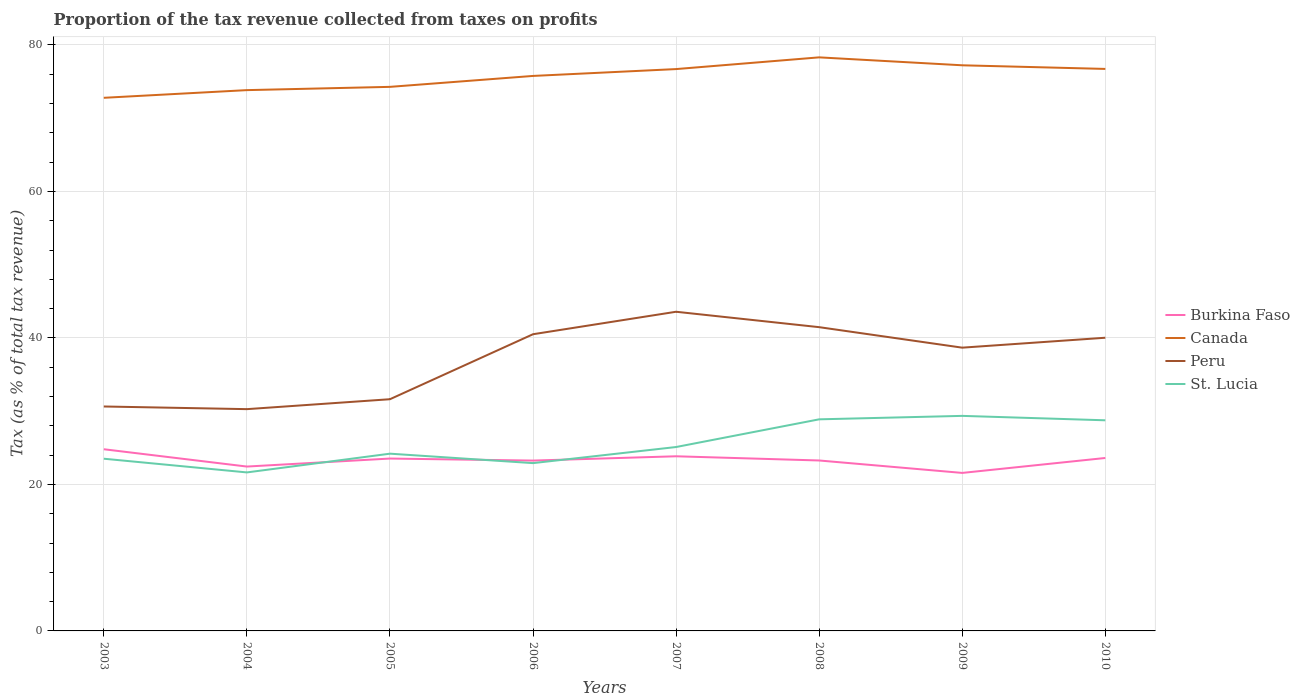How many different coloured lines are there?
Provide a short and direct response. 4. Is the number of lines equal to the number of legend labels?
Give a very brief answer. Yes. Across all years, what is the maximum proportion of the tax revenue collected in St. Lucia?
Give a very brief answer. 21.64. In which year was the proportion of the tax revenue collected in Burkina Faso maximum?
Keep it short and to the point. 2009. What is the total proportion of the tax revenue collected in St. Lucia in the graph?
Provide a short and direct response. -2.2. What is the difference between the highest and the second highest proportion of the tax revenue collected in Burkina Faso?
Offer a terse response. 3.23. What is the difference between the highest and the lowest proportion of the tax revenue collected in Canada?
Provide a short and direct response. 5. Is the proportion of the tax revenue collected in St. Lucia strictly greater than the proportion of the tax revenue collected in Peru over the years?
Offer a very short reply. Yes. Are the values on the major ticks of Y-axis written in scientific E-notation?
Make the answer very short. No. Does the graph contain any zero values?
Give a very brief answer. No. How many legend labels are there?
Keep it short and to the point. 4. How are the legend labels stacked?
Give a very brief answer. Vertical. What is the title of the graph?
Your answer should be compact. Proportion of the tax revenue collected from taxes on profits. Does "Panama" appear as one of the legend labels in the graph?
Offer a terse response. No. What is the label or title of the X-axis?
Your answer should be compact. Years. What is the label or title of the Y-axis?
Keep it short and to the point. Tax (as % of total tax revenue). What is the Tax (as % of total tax revenue) of Burkina Faso in 2003?
Ensure brevity in your answer.  24.8. What is the Tax (as % of total tax revenue) in Canada in 2003?
Your response must be concise. 72.78. What is the Tax (as % of total tax revenue) of Peru in 2003?
Your answer should be very brief. 30.64. What is the Tax (as % of total tax revenue) in St. Lucia in 2003?
Offer a terse response. 23.51. What is the Tax (as % of total tax revenue) in Burkina Faso in 2004?
Your response must be concise. 22.44. What is the Tax (as % of total tax revenue) of Canada in 2004?
Your answer should be compact. 73.83. What is the Tax (as % of total tax revenue) of Peru in 2004?
Provide a short and direct response. 30.28. What is the Tax (as % of total tax revenue) of St. Lucia in 2004?
Ensure brevity in your answer.  21.64. What is the Tax (as % of total tax revenue) in Burkina Faso in 2005?
Offer a terse response. 23.53. What is the Tax (as % of total tax revenue) of Canada in 2005?
Your answer should be very brief. 74.28. What is the Tax (as % of total tax revenue) in Peru in 2005?
Ensure brevity in your answer.  31.63. What is the Tax (as % of total tax revenue) in St. Lucia in 2005?
Keep it short and to the point. 24.2. What is the Tax (as % of total tax revenue) of Burkina Faso in 2006?
Your response must be concise. 23.26. What is the Tax (as % of total tax revenue) in Canada in 2006?
Keep it short and to the point. 75.77. What is the Tax (as % of total tax revenue) of Peru in 2006?
Your response must be concise. 40.5. What is the Tax (as % of total tax revenue) of St. Lucia in 2006?
Keep it short and to the point. 22.91. What is the Tax (as % of total tax revenue) of Burkina Faso in 2007?
Ensure brevity in your answer.  23.84. What is the Tax (as % of total tax revenue) of Canada in 2007?
Make the answer very short. 76.7. What is the Tax (as % of total tax revenue) of Peru in 2007?
Offer a very short reply. 43.57. What is the Tax (as % of total tax revenue) in St. Lucia in 2007?
Make the answer very short. 25.11. What is the Tax (as % of total tax revenue) of Burkina Faso in 2008?
Your answer should be very brief. 23.27. What is the Tax (as % of total tax revenue) in Canada in 2008?
Your answer should be compact. 78.3. What is the Tax (as % of total tax revenue) of Peru in 2008?
Ensure brevity in your answer.  41.47. What is the Tax (as % of total tax revenue) in St. Lucia in 2008?
Offer a very short reply. 28.89. What is the Tax (as % of total tax revenue) in Burkina Faso in 2009?
Offer a very short reply. 21.57. What is the Tax (as % of total tax revenue) in Canada in 2009?
Give a very brief answer. 77.22. What is the Tax (as % of total tax revenue) in Peru in 2009?
Make the answer very short. 38.67. What is the Tax (as % of total tax revenue) of St. Lucia in 2009?
Keep it short and to the point. 29.36. What is the Tax (as % of total tax revenue) in Burkina Faso in 2010?
Provide a short and direct response. 23.61. What is the Tax (as % of total tax revenue) in Canada in 2010?
Ensure brevity in your answer.  76.72. What is the Tax (as % of total tax revenue) of Peru in 2010?
Keep it short and to the point. 40.03. What is the Tax (as % of total tax revenue) in St. Lucia in 2010?
Your answer should be very brief. 28.76. Across all years, what is the maximum Tax (as % of total tax revenue) of Burkina Faso?
Offer a very short reply. 24.8. Across all years, what is the maximum Tax (as % of total tax revenue) of Canada?
Offer a very short reply. 78.3. Across all years, what is the maximum Tax (as % of total tax revenue) in Peru?
Keep it short and to the point. 43.57. Across all years, what is the maximum Tax (as % of total tax revenue) of St. Lucia?
Your response must be concise. 29.36. Across all years, what is the minimum Tax (as % of total tax revenue) in Burkina Faso?
Provide a short and direct response. 21.57. Across all years, what is the minimum Tax (as % of total tax revenue) of Canada?
Offer a terse response. 72.78. Across all years, what is the minimum Tax (as % of total tax revenue) of Peru?
Your response must be concise. 30.28. Across all years, what is the minimum Tax (as % of total tax revenue) in St. Lucia?
Your answer should be very brief. 21.64. What is the total Tax (as % of total tax revenue) of Burkina Faso in the graph?
Your answer should be compact. 186.32. What is the total Tax (as % of total tax revenue) of Canada in the graph?
Your response must be concise. 605.61. What is the total Tax (as % of total tax revenue) of Peru in the graph?
Ensure brevity in your answer.  296.79. What is the total Tax (as % of total tax revenue) of St. Lucia in the graph?
Give a very brief answer. 204.37. What is the difference between the Tax (as % of total tax revenue) of Burkina Faso in 2003 and that in 2004?
Provide a succinct answer. 2.36. What is the difference between the Tax (as % of total tax revenue) of Canada in 2003 and that in 2004?
Offer a very short reply. -1.05. What is the difference between the Tax (as % of total tax revenue) of Peru in 2003 and that in 2004?
Offer a very short reply. 0.36. What is the difference between the Tax (as % of total tax revenue) of St. Lucia in 2003 and that in 2004?
Offer a terse response. 1.87. What is the difference between the Tax (as % of total tax revenue) of Burkina Faso in 2003 and that in 2005?
Offer a terse response. 1.27. What is the difference between the Tax (as % of total tax revenue) in Canada in 2003 and that in 2005?
Keep it short and to the point. -1.49. What is the difference between the Tax (as % of total tax revenue) in Peru in 2003 and that in 2005?
Make the answer very short. -0.99. What is the difference between the Tax (as % of total tax revenue) in St. Lucia in 2003 and that in 2005?
Ensure brevity in your answer.  -0.69. What is the difference between the Tax (as % of total tax revenue) in Burkina Faso in 2003 and that in 2006?
Keep it short and to the point. 1.55. What is the difference between the Tax (as % of total tax revenue) in Canada in 2003 and that in 2006?
Your response must be concise. -2.99. What is the difference between the Tax (as % of total tax revenue) in Peru in 2003 and that in 2006?
Your answer should be very brief. -9.86. What is the difference between the Tax (as % of total tax revenue) of St. Lucia in 2003 and that in 2006?
Make the answer very short. 0.6. What is the difference between the Tax (as % of total tax revenue) in Burkina Faso in 2003 and that in 2007?
Your answer should be compact. 0.96. What is the difference between the Tax (as % of total tax revenue) in Canada in 2003 and that in 2007?
Provide a short and direct response. -3.92. What is the difference between the Tax (as % of total tax revenue) in Peru in 2003 and that in 2007?
Offer a terse response. -12.93. What is the difference between the Tax (as % of total tax revenue) in St. Lucia in 2003 and that in 2007?
Provide a short and direct response. -1.6. What is the difference between the Tax (as % of total tax revenue) in Burkina Faso in 2003 and that in 2008?
Make the answer very short. 1.54. What is the difference between the Tax (as % of total tax revenue) of Canada in 2003 and that in 2008?
Your answer should be compact. -5.52. What is the difference between the Tax (as % of total tax revenue) in Peru in 2003 and that in 2008?
Your response must be concise. -10.83. What is the difference between the Tax (as % of total tax revenue) of St. Lucia in 2003 and that in 2008?
Make the answer very short. -5.38. What is the difference between the Tax (as % of total tax revenue) of Burkina Faso in 2003 and that in 2009?
Your answer should be compact. 3.23. What is the difference between the Tax (as % of total tax revenue) in Canada in 2003 and that in 2009?
Offer a very short reply. -4.44. What is the difference between the Tax (as % of total tax revenue) of Peru in 2003 and that in 2009?
Provide a short and direct response. -8.03. What is the difference between the Tax (as % of total tax revenue) in St. Lucia in 2003 and that in 2009?
Offer a terse response. -5.85. What is the difference between the Tax (as % of total tax revenue) of Burkina Faso in 2003 and that in 2010?
Your answer should be very brief. 1.19. What is the difference between the Tax (as % of total tax revenue) in Canada in 2003 and that in 2010?
Keep it short and to the point. -3.94. What is the difference between the Tax (as % of total tax revenue) of Peru in 2003 and that in 2010?
Give a very brief answer. -9.39. What is the difference between the Tax (as % of total tax revenue) of St. Lucia in 2003 and that in 2010?
Your answer should be compact. -5.25. What is the difference between the Tax (as % of total tax revenue) of Burkina Faso in 2004 and that in 2005?
Your answer should be compact. -1.09. What is the difference between the Tax (as % of total tax revenue) in Canada in 2004 and that in 2005?
Keep it short and to the point. -0.45. What is the difference between the Tax (as % of total tax revenue) in Peru in 2004 and that in 2005?
Provide a succinct answer. -1.35. What is the difference between the Tax (as % of total tax revenue) in St. Lucia in 2004 and that in 2005?
Offer a very short reply. -2.56. What is the difference between the Tax (as % of total tax revenue) of Burkina Faso in 2004 and that in 2006?
Your answer should be compact. -0.82. What is the difference between the Tax (as % of total tax revenue) of Canada in 2004 and that in 2006?
Offer a terse response. -1.94. What is the difference between the Tax (as % of total tax revenue) in Peru in 2004 and that in 2006?
Give a very brief answer. -10.23. What is the difference between the Tax (as % of total tax revenue) of St. Lucia in 2004 and that in 2006?
Ensure brevity in your answer.  -1.27. What is the difference between the Tax (as % of total tax revenue) of Burkina Faso in 2004 and that in 2007?
Ensure brevity in your answer.  -1.4. What is the difference between the Tax (as % of total tax revenue) of Canada in 2004 and that in 2007?
Give a very brief answer. -2.87. What is the difference between the Tax (as % of total tax revenue) in Peru in 2004 and that in 2007?
Offer a terse response. -13.3. What is the difference between the Tax (as % of total tax revenue) in St. Lucia in 2004 and that in 2007?
Keep it short and to the point. -3.47. What is the difference between the Tax (as % of total tax revenue) in Burkina Faso in 2004 and that in 2008?
Make the answer very short. -0.83. What is the difference between the Tax (as % of total tax revenue) of Canada in 2004 and that in 2008?
Offer a very short reply. -4.47. What is the difference between the Tax (as % of total tax revenue) of Peru in 2004 and that in 2008?
Your answer should be compact. -11.19. What is the difference between the Tax (as % of total tax revenue) in St. Lucia in 2004 and that in 2008?
Your response must be concise. -7.25. What is the difference between the Tax (as % of total tax revenue) of Burkina Faso in 2004 and that in 2009?
Offer a very short reply. 0.87. What is the difference between the Tax (as % of total tax revenue) in Canada in 2004 and that in 2009?
Provide a short and direct response. -3.39. What is the difference between the Tax (as % of total tax revenue) in Peru in 2004 and that in 2009?
Ensure brevity in your answer.  -8.39. What is the difference between the Tax (as % of total tax revenue) in St. Lucia in 2004 and that in 2009?
Offer a very short reply. -7.72. What is the difference between the Tax (as % of total tax revenue) of Burkina Faso in 2004 and that in 2010?
Give a very brief answer. -1.17. What is the difference between the Tax (as % of total tax revenue) of Canada in 2004 and that in 2010?
Make the answer very short. -2.89. What is the difference between the Tax (as % of total tax revenue) in Peru in 2004 and that in 2010?
Your response must be concise. -9.75. What is the difference between the Tax (as % of total tax revenue) in St. Lucia in 2004 and that in 2010?
Give a very brief answer. -7.12. What is the difference between the Tax (as % of total tax revenue) in Burkina Faso in 2005 and that in 2006?
Your answer should be very brief. 0.28. What is the difference between the Tax (as % of total tax revenue) in Canada in 2005 and that in 2006?
Give a very brief answer. -1.49. What is the difference between the Tax (as % of total tax revenue) of Peru in 2005 and that in 2006?
Keep it short and to the point. -8.87. What is the difference between the Tax (as % of total tax revenue) of St. Lucia in 2005 and that in 2006?
Keep it short and to the point. 1.29. What is the difference between the Tax (as % of total tax revenue) in Burkina Faso in 2005 and that in 2007?
Make the answer very short. -0.31. What is the difference between the Tax (as % of total tax revenue) in Canada in 2005 and that in 2007?
Offer a terse response. -2.43. What is the difference between the Tax (as % of total tax revenue) in Peru in 2005 and that in 2007?
Your answer should be very brief. -11.94. What is the difference between the Tax (as % of total tax revenue) in St. Lucia in 2005 and that in 2007?
Offer a terse response. -0.91. What is the difference between the Tax (as % of total tax revenue) of Burkina Faso in 2005 and that in 2008?
Offer a terse response. 0.26. What is the difference between the Tax (as % of total tax revenue) in Canada in 2005 and that in 2008?
Your answer should be compact. -4.03. What is the difference between the Tax (as % of total tax revenue) in Peru in 2005 and that in 2008?
Your answer should be compact. -9.84. What is the difference between the Tax (as % of total tax revenue) of St. Lucia in 2005 and that in 2008?
Give a very brief answer. -4.69. What is the difference between the Tax (as % of total tax revenue) of Burkina Faso in 2005 and that in 2009?
Your answer should be very brief. 1.96. What is the difference between the Tax (as % of total tax revenue) of Canada in 2005 and that in 2009?
Offer a terse response. -2.94. What is the difference between the Tax (as % of total tax revenue) of Peru in 2005 and that in 2009?
Offer a terse response. -7.04. What is the difference between the Tax (as % of total tax revenue) of St. Lucia in 2005 and that in 2009?
Provide a short and direct response. -5.16. What is the difference between the Tax (as % of total tax revenue) in Burkina Faso in 2005 and that in 2010?
Your response must be concise. -0.08. What is the difference between the Tax (as % of total tax revenue) of Canada in 2005 and that in 2010?
Ensure brevity in your answer.  -2.45. What is the difference between the Tax (as % of total tax revenue) in Peru in 2005 and that in 2010?
Keep it short and to the point. -8.39. What is the difference between the Tax (as % of total tax revenue) in St. Lucia in 2005 and that in 2010?
Offer a very short reply. -4.56. What is the difference between the Tax (as % of total tax revenue) of Burkina Faso in 2006 and that in 2007?
Offer a very short reply. -0.59. What is the difference between the Tax (as % of total tax revenue) in Canada in 2006 and that in 2007?
Your answer should be very brief. -0.94. What is the difference between the Tax (as % of total tax revenue) of Peru in 2006 and that in 2007?
Your response must be concise. -3.07. What is the difference between the Tax (as % of total tax revenue) of St. Lucia in 2006 and that in 2007?
Make the answer very short. -2.2. What is the difference between the Tax (as % of total tax revenue) of Burkina Faso in 2006 and that in 2008?
Provide a short and direct response. -0.01. What is the difference between the Tax (as % of total tax revenue) in Canada in 2006 and that in 2008?
Your response must be concise. -2.54. What is the difference between the Tax (as % of total tax revenue) of Peru in 2006 and that in 2008?
Your response must be concise. -0.96. What is the difference between the Tax (as % of total tax revenue) in St. Lucia in 2006 and that in 2008?
Provide a succinct answer. -5.98. What is the difference between the Tax (as % of total tax revenue) in Burkina Faso in 2006 and that in 2009?
Your answer should be very brief. 1.68. What is the difference between the Tax (as % of total tax revenue) in Canada in 2006 and that in 2009?
Your answer should be very brief. -1.45. What is the difference between the Tax (as % of total tax revenue) of Peru in 2006 and that in 2009?
Your response must be concise. 1.83. What is the difference between the Tax (as % of total tax revenue) in St. Lucia in 2006 and that in 2009?
Offer a very short reply. -6.45. What is the difference between the Tax (as % of total tax revenue) in Burkina Faso in 2006 and that in 2010?
Offer a terse response. -0.36. What is the difference between the Tax (as % of total tax revenue) of Canada in 2006 and that in 2010?
Offer a very short reply. -0.96. What is the difference between the Tax (as % of total tax revenue) in Peru in 2006 and that in 2010?
Offer a terse response. 0.48. What is the difference between the Tax (as % of total tax revenue) of St. Lucia in 2006 and that in 2010?
Ensure brevity in your answer.  -5.85. What is the difference between the Tax (as % of total tax revenue) in Burkina Faso in 2007 and that in 2008?
Keep it short and to the point. 0.57. What is the difference between the Tax (as % of total tax revenue) in Canada in 2007 and that in 2008?
Make the answer very short. -1.6. What is the difference between the Tax (as % of total tax revenue) of Peru in 2007 and that in 2008?
Provide a short and direct response. 2.1. What is the difference between the Tax (as % of total tax revenue) in St. Lucia in 2007 and that in 2008?
Make the answer very short. -3.78. What is the difference between the Tax (as % of total tax revenue) in Burkina Faso in 2007 and that in 2009?
Offer a very short reply. 2.27. What is the difference between the Tax (as % of total tax revenue) of Canada in 2007 and that in 2009?
Your answer should be compact. -0.52. What is the difference between the Tax (as % of total tax revenue) in Peru in 2007 and that in 2009?
Provide a short and direct response. 4.9. What is the difference between the Tax (as % of total tax revenue) in St. Lucia in 2007 and that in 2009?
Your answer should be very brief. -4.25. What is the difference between the Tax (as % of total tax revenue) in Burkina Faso in 2007 and that in 2010?
Your response must be concise. 0.23. What is the difference between the Tax (as % of total tax revenue) of Canada in 2007 and that in 2010?
Offer a very short reply. -0.02. What is the difference between the Tax (as % of total tax revenue) in Peru in 2007 and that in 2010?
Give a very brief answer. 3.55. What is the difference between the Tax (as % of total tax revenue) in St. Lucia in 2007 and that in 2010?
Offer a terse response. -3.65. What is the difference between the Tax (as % of total tax revenue) in Burkina Faso in 2008 and that in 2009?
Ensure brevity in your answer.  1.7. What is the difference between the Tax (as % of total tax revenue) of Canada in 2008 and that in 2009?
Your answer should be compact. 1.08. What is the difference between the Tax (as % of total tax revenue) in Peru in 2008 and that in 2009?
Make the answer very short. 2.8. What is the difference between the Tax (as % of total tax revenue) in St. Lucia in 2008 and that in 2009?
Your answer should be compact. -0.47. What is the difference between the Tax (as % of total tax revenue) in Burkina Faso in 2008 and that in 2010?
Your response must be concise. -0.34. What is the difference between the Tax (as % of total tax revenue) in Canada in 2008 and that in 2010?
Offer a very short reply. 1.58. What is the difference between the Tax (as % of total tax revenue) of Peru in 2008 and that in 2010?
Your answer should be very brief. 1.44. What is the difference between the Tax (as % of total tax revenue) of St. Lucia in 2008 and that in 2010?
Your response must be concise. 0.13. What is the difference between the Tax (as % of total tax revenue) of Burkina Faso in 2009 and that in 2010?
Provide a succinct answer. -2.04. What is the difference between the Tax (as % of total tax revenue) of Canada in 2009 and that in 2010?
Ensure brevity in your answer.  0.5. What is the difference between the Tax (as % of total tax revenue) in Peru in 2009 and that in 2010?
Give a very brief answer. -1.35. What is the difference between the Tax (as % of total tax revenue) in St. Lucia in 2009 and that in 2010?
Give a very brief answer. 0.6. What is the difference between the Tax (as % of total tax revenue) of Burkina Faso in 2003 and the Tax (as % of total tax revenue) of Canada in 2004?
Your answer should be compact. -49.03. What is the difference between the Tax (as % of total tax revenue) of Burkina Faso in 2003 and the Tax (as % of total tax revenue) of Peru in 2004?
Your response must be concise. -5.47. What is the difference between the Tax (as % of total tax revenue) of Burkina Faso in 2003 and the Tax (as % of total tax revenue) of St. Lucia in 2004?
Keep it short and to the point. 3.16. What is the difference between the Tax (as % of total tax revenue) of Canada in 2003 and the Tax (as % of total tax revenue) of Peru in 2004?
Keep it short and to the point. 42.51. What is the difference between the Tax (as % of total tax revenue) in Canada in 2003 and the Tax (as % of total tax revenue) in St. Lucia in 2004?
Provide a succinct answer. 51.14. What is the difference between the Tax (as % of total tax revenue) in Peru in 2003 and the Tax (as % of total tax revenue) in St. Lucia in 2004?
Give a very brief answer. 9. What is the difference between the Tax (as % of total tax revenue) of Burkina Faso in 2003 and the Tax (as % of total tax revenue) of Canada in 2005?
Provide a short and direct response. -49.47. What is the difference between the Tax (as % of total tax revenue) of Burkina Faso in 2003 and the Tax (as % of total tax revenue) of Peru in 2005?
Keep it short and to the point. -6.83. What is the difference between the Tax (as % of total tax revenue) in Burkina Faso in 2003 and the Tax (as % of total tax revenue) in St. Lucia in 2005?
Keep it short and to the point. 0.61. What is the difference between the Tax (as % of total tax revenue) of Canada in 2003 and the Tax (as % of total tax revenue) of Peru in 2005?
Offer a very short reply. 41.15. What is the difference between the Tax (as % of total tax revenue) of Canada in 2003 and the Tax (as % of total tax revenue) of St. Lucia in 2005?
Your answer should be very brief. 48.58. What is the difference between the Tax (as % of total tax revenue) of Peru in 2003 and the Tax (as % of total tax revenue) of St. Lucia in 2005?
Provide a short and direct response. 6.44. What is the difference between the Tax (as % of total tax revenue) in Burkina Faso in 2003 and the Tax (as % of total tax revenue) in Canada in 2006?
Give a very brief answer. -50.96. What is the difference between the Tax (as % of total tax revenue) in Burkina Faso in 2003 and the Tax (as % of total tax revenue) in Peru in 2006?
Offer a terse response. -15.7. What is the difference between the Tax (as % of total tax revenue) of Burkina Faso in 2003 and the Tax (as % of total tax revenue) of St. Lucia in 2006?
Make the answer very short. 1.9. What is the difference between the Tax (as % of total tax revenue) in Canada in 2003 and the Tax (as % of total tax revenue) in Peru in 2006?
Make the answer very short. 32.28. What is the difference between the Tax (as % of total tax revenue) of Canada in 2003 and the Tax (as % of total tax revenue) of St. Lucia in 2006?
Provide a short and direct response. 49.87. What is the difference between the Tax (as % of total tax revenue) in Peru in 2003 and the Tax (as % of total tax revenue) in St. Lucia in 2006?
Provide a short and direct response. 7.73. What is the difference between the Tax (as % of total tax revenue) of Burkina Faso in 2003 and the Tax (as % of total tax revenue) of Canada in 2007?
Provide a succinct answer. -51.9. What is the difference between the Tax (as % of total tax revenue) in Burkina Faso in 2003 and the Tax (as % of total tax revenue) in Peru in 2007?
Your answer should be very brief. -18.77. What is the difference between the Tax (as % of total tax revenue) of Burkina Faso in 2003 and the Tax (as % of total tax revenue) of St. Lucia in 2007?
Offer a very short reply. -0.3. What is the difference between the Tax (as % of total tax revenue) of Canada in 2003 and the Tax (as % of total tax revenue) of Peru in 2007?
Keep it short and to the point. 29.21. What is the difference between the Tax (as % of total tax revenue) of Canada in 2003 and the Tax (as % of total tax revenue) of St. Lucia in 2007?
Give a very brief answer. 47.68. What is the difference between the Tax (as % of total tax revenue) of Peru in 2003 and the Tax (as % of total tax revenue) of St. Lucia in 2007?
Provide a succinct answer. 5.53. What is the difference between the Tax (as % of total tax revenue) in Burkina Faso in 2003 and the Tax (as % of total tax revenue) in Canada in 2008?
Offer a terse response. -53.5. What is the difference between the Tax (as % of total tax revenue) of Burkina Faso in 2003 and the Tax (as % of total tax revenue) of Peru in 2008?
Keep it short and to the point. -16.67. What is the difference between the Tax (as % of total tax revenue) of Burkina Faso in 2003 and the Tax (as % of total tax revenue) of St. Lucia in 2008?
Your answer should be very brief. -4.08. What is the difference between the Tax (as % of total tax revenue) in Canada in 2003 and the Tax (as % of total tax revenue) in Peru in 2008?
Your response must be concise. 31.31. What is the difference between the Tax (as % of total tax revenue) in Canada in 2003 and the Tax (as % of total tax revenue) in St. Lucia in 2008?
Ensure brevity in your answer.  43.89. What is the difference between the Tax (as % of total tax revenue) in Peru in 2003 and the Tax (as % of total tax revenue) in St. Lucia in 2008?
Offer a terse response. 1.75. What is the difference between the Tax (as % of total tax revenue) of Burkina Faso in 2003 and the Tax (as % of total tax revenue) of Canada in 2009?
Offer a terse response. -52.42. What is the difference between the Tax (as % of total tax revenue) in Burkina Faso in 2003 and the Tax (as % of total tax revenue) in Peru in 2009?
Offer a terse response. -13.87. What is the difference between the Tax (as % of total tax revenue) of Burkina Faso in 2003 and the Tax (as % of total tax revenue) of St. Lucia in 2009?
Your response must be concise. -4.56. What is the difference between the Tax (as % of total tax revenue) in Canada in 2003 and the Tax (as % of total tax revenue) in Peru in 2009?
Offer a terse response. 34.11. What is the difference between the Tax (as % of total tax revenue) of Canada in 2003 and the Tax (as % of total tax revenue) of St. Lucia in 2009?
Your response must be concise. 43.42. What is the difference between the Tax (as % of total tax revenue) in Peru in 2003 and the Tax (as % of total tax revenue) in St. Lucia in 2009?
Your response must be concise. 1.28. What is the difference between the Tax (as % of total tax revenue) of Burkina Faso in 2003 and the Tax (as % of total tax revenue) of Canada in 2010?
Your answer should be very brief. -51.92. What is the difference between the Tax (as % of total tax revenue) in Burkina Faso in 2003 and the Tax (as % of total tax revenue) in Peru in 2010?
Ensure brevity in your answer.  -15.22. What is the difference between the Tax (as % of total tax revenue) of Burkina Faso in 2003 and the Tax (as % of total tax revenue) of St. Lucia in 2010?
Provide a short and direct response. -3.95. What is the difference between the Tax (as % of total tax revenue) in Canada in 2003 and the Tax (as % of total tax revenue) in Peru in 2010?
Offer a very short reply. 32.76. What is the difference between the Tax (as % of total tax revenue) of Canada in 2003 and the Tax (as % of total tax revenue) of St. Lucia in 2010?
Provide a succinct answer. 44.03. What is the difference between the Tax (as % of total tax revenue) in Peru in 2003 and the Tax (as % of total tax revenue) in St. Lucia in 2010?
Your answer should be compact. 1.88. What is the difference between the Tax (as % of total tax revenue) in Burkina Faso in 2004 and the Tax (as % of total tax revenue) in Canada in 2005?
Ensure brevity in your answer.  -51.84. What is the difference between the Tax (as % of total tax revenue) of Burkina Faso in 2004 and the Tax (as % of total tax revenue) of Peru in 2005?
Offer a terse response. -9.19. What is the difference between the Tax (as % of total tax revenue) of Burkina Faso in 2004 and the Tax (as % of total tax revenue) of St. Lucia in 2005?
Your answer should be very brief. -1.76. What is the difference between the Tax (as % of total tax revenue) in Canada in 2004 and the Tax (as % of total tax revenue) in Peru in 2005?
Keep it short and to the point. 42.2. What is the difference between the Tax (as % of total tax revenue) in Canada in 2004 and the Tax (as % of total tax revenue) in St. Lucia in 2005?
Your answer should be very brief. 49.63. What is the difference between the Tax (as % of total tax revenue) of Peru in 2004 and the Tax (as % of total tax revenue) of St. Lucia in 2005?
Your answer should be very brief. 6.08. What is the difference between the Tax (as % of total tax revenue) of Burkina Faso in 2004 and the Tax (as % of total tax revenue) of Canada in 2006?
Ensure brevity in your answer.  -53.33. What is the difference between the Tax (as % of total tax revenue) of Burkina Faso in 2004 and the Tax (as % of total tax revenue) of Peru in 2006?
Provide a short and direct response. -18.07. What is the difference between the Tax (as % of total tax revenue) of Burkina Faso in 2004 and the Tax (as % of total tax revenue) of St. Lucia in 2006?
Offer a very short reply. -0.47. What is the difference between the Tax (as % of total tax revenue) in Canada in 2004 and the Tax (as % of total tax revenue) in Peru in 2006?
Provide a short and direct response. 33.33. What is the difference between the Tax (as % of total tax revenue) in Canada in 2004 and the Tax (as % of total tax revenue) in St. Lucia in 2006?
Provide a succinct answer. 50.92. What is the difference between the Tax (as % of total tax revenue) of Peru in 2004 and the Tax (as % of total tax revenue) of St. Lucia in 2006?
Keep it short and to the point. 7.37. What is the difference between the Tax (as % of total tax revenue) in Burkina Faso in 2004 and the Tax (as % of total tax revenue) in Canada in 2007?
Offer a terse response. -54.26. What is the difference between the Tax (as % of total tax revenue) of Burkina Faso in 2004 and the Tax (as % of total tax revenue) of Peru in 2007?
Keep it short and to the point. -21.13. What is the difference between the Tax (as % of total tax revenue) of Burkina Faso in 2004 and the Tax (as % of total tax revenue) of St. Lucia in 2007?
Keep it short and to the point. -2.67. What is the difference between the Tax (as % of total tax revenue) of Canada in 2004 and the Tax (as % of total tax revenue) of Peru in 2007?
Make the answer very short. 30.26. What is the difference between the Tax (as % of total tax revenue) in Canada in 2004 and the Tax (as % of total tax revenue) in St. Lucia in 2007?
Offer a very short reply. 48.72. What is the difference between the Tax (as % of total tax revenue) in Peru in 2004 and the Tax (as % of total tax revenue) in St. Lucia in 2007?
Ensure brevity in your answer.  5.17. What is the difference between the Tax (as % of total tax revenue) of Burkina Faso in 2004 and the Tax (as % of total tax revenue) of Canada in 2008?
Provide a succinct answer. -55.87. What is the difference between the Tax (as % of total tax revenue) in Burkina Faso in 2004 and the Tax (as % of total tax revenue) in Peru in 2008?
Ensure brevity in your answer.  -19.03. What is the difference between the Tax (as % of total tax revenue) of Burkina Faso in 2004 and the Tax (as % of total tax revenue) of St. Lucia in 2008?
Offer a very short reply. -6.45. What is the difference between the Tax (as % of total tax revenue) of Canada in 2004 and the Tax (as % of total tax revenue) of Peru in 2008?
Your response must be concise. 32.36. What is the difference between the Tax (as % of total tax revenue) in Canada in 2004 and the Tax (as % of total tax revenue) in St. Lucia in 2008?
Make the answer very short. 44.94. What is the difference between the Tax (as % of total tax revenue) in Peru in 2004 and the Tax (as % of total tax revenue) in St. Lucia in 2008?
Offer a very short reply. 1.39. What is the difference between the Tax (as % of total tax revenue) in Burkina Faso in 2004 and the Tax (as % of total tax revenue) in Canada in 2009?
Give a very brief answer. -54.78. What is the difference between the Tax (as % of total tax revenue) of Burkina Faso in 2004 and the Tax (as % of total tax revenue) of Peru in 2009?
Ensure brevity in your answer.  -16.23. What is the difference between the Tax (as % of total tax revenue) of Burkina Faso in 2004 and the Tax (as % of total tax revenue) of St. Lucia in 2009?
Offer a terse response. -6.92. What is the difference between the Tax (as % of total tax revenue) in Canada in 2004 and the Tax (as % of total tax revenue) in Peru in 2009?
Your answer should be compact. 35.16. What is the difference between the Tax (as % of total tax revenue) of Canada in 2004 and the Tax (as % of total tax revenue) of St. Lucia in 2009?
Provide a short and direct response. 44.47. What is the difference between the Tax (as % of total tax revenue) of Peru in 2004 and the Tax (as % of total tax revenue) of St. Lucia in 2009?
Keep it short and to the point. 0.92. What is the difference between the Tax (as % of total tax revenue) of Burkina Faso in 2004 and the Tax (as % of total tax revenue) of Canada in 2010?
Ensure brevity in your answer.  -54.28. What is the difference between the Tax (as % of total tax revenue) in Burkina Faso in 2004 and the Tax (as % of total tax revenue) in Peru in 2010?
Offer a very short reply. -17.59. What is the difference between the Tax (as % of total tax revenue) of Burkina Faso in 2004 and the Tax (as % of total tax revenue) of St. Lucia in 2010?
Your answer should be very brief. -6.32. What is the difference between the Tax (as % of total tax revenue) of Canada in 2004 and the Tax (as % of total tax revenue) of Peru in 2010?
Offer a very short reply. 33.8. What is the difference between the Tax (as % of total tax revenue) of Canada in 2004 and the Tax (as % of total tax revenue) of St. Lucia in 2010?
Provide a succinct answer. 45.07. What is the difference between the Tax (as % of total tax revenue) of Peru in 2004 and the Tax (as % of total tax revenue) of St. Lucia in 2010?
Ensure brevity in your answer.  1.52. What is the difference between the Tax (as % of total tax revenue) in Burkina Faso in 2005 and the Tax (as % of total tax revenue) in Canada in 2006?
Provide a short and direct response. -52.24. What is the difference between the Tax (as % of total tax revenue) in Burkina Faso in 2005 and the Tax (as % of total tax revenue) in Peru in 2006?
Offer a terse response. -16.97. What is the difference between the Tax (as % of total tax revenue) of Burkina Faso in 2005 and the Tax (as % of total tax revenue) of St. Lucia in 2006?
Provide a short and direct response. 0.62. What is the difference between the Tax (as % of total tax revenue) in Canada in 2005 and the Tax (as % of total tax revenue) in Peru in 2006?
Provide a succinct answer. 33.77. What is the difference between the Tax (as % of total tax revenue) in Canada in 2005 and the Tax (as % of total tax revenue) in St. Lucia in 2006?
Provide a short and direct response. 51.37. What is the difference between the Tax (as % of total tax revenue) of Peru in 2005 and the Tax (as % of total tax revenue) of St. Lucia in 2006?
Provide a short and direct response. 8.72. What is the difference between the Tax (as % of total tax revenue) of Burkina Faso in 2005 and the Tax (as % of total tax revenue) of Canada in 2007?
Your response must be concise. -53.17. What is the difference between the Tax (as % of total tax revenue) in Burkina Faso in 2005 and the Tax (as % of total tax revenue) in Peru in 2007?
Give a very brief answer. -20.04. What is the difference between the Tax (as % of total tax revenue) of Burkina Faso in 2005 and the Tax (as % of total tax revenue) of St. Lucia in 2007?
Provide a short and direct response. -1.57. What is the difference between the Tax (as % of total tax revenue) in Canada in 2005 and the Tax (as % of total tax revenue) in Peru in 2007?
Your answer should be compact. 30.7. What is the difference between the Tax (as % of total tax revenue) of Canada in 2005 and the Tax (as % of total tax revenue) of St. Lucia in 2007?
Your answer should be very brief. 49.17. What is the difference between the Tax (as % of total tax revenue) in Peru in 2005 and the Tax (as % of total tax revenue) in St. Lucia in 2007?
Ensure brevity in your answer.  6.53. What is the difference between the Tax (as % of total tax revenue) in Burkina Faso in 2005 and the Tax (as % of total tax revenue) in Canada in 2008?
Keep it short and to the point. -54.77. What is the difference between the Tax (as % of total tax revenue) of Burkina Faso in 2005 and the Tax (as % of total tax revenue) of Peru in 2008?
Offer a terse response. -17.94. What is the difference between the Tax (as % of total tax revenue) of Burkina Faso in 2005 and the Tax (as % of total tax revenue) of St. Lucia in 2008?
Keep it short and to the point. -5.36. What is the difference between the Tax (as % of total tax revenue) in Canada in 2005 and the Tax (as % of total tax revenue) in Peru in 2008?
Give a very brief answer. 32.81. What is the difference between the Tax (as % of total tax revenue) of Canada in 2005 and the Tax (as % of total tax revenue) of St. Lucia in 2008?
Your answer should be compact. 45.39. What is the difference between the Tax (as % of total tax revenue) in Peru in 2005 and the Tax (as % of total tax revenue) in St. Lucia in 2008?
Provide a succinct answer. 2.74. What is the difference between the Tax (as % of total tax revenue) in Burkina Faso in 2005 and the Tax (as % of total tax revenue) in Canada in 2009?
Give a very brief answer. -53.69. What is the difference between the Tax (as % of total tax revenue) in Burkina Faso in 2005 and the Tax (as % of total tax revenue) in Peru in 2009?
Keep it short and to the point. -15.14. What is the difference between the Tax (as % of total tax revenue) in Burkina Faso in 2005 and the Tax (as % of total tax revenue) in St. Lucia in 2009?
Provide a succinct answer. -5.83. What is the difference between the Tax (as % of total tax revenue) in Canada in 2005 and the Tax (as % of total tax revenue) in Peru in 2009?
Your answer should be compact. 35.6. What is the difference between the Tax (as % of total tax revenue) of Canada in 2005 and the Tax (as % of total tax revenue) of St. Lucia in 2009?
Provide a succinct answer. 44.92. What is the difference between the Tax (as % of total tax revenue) of Peru in 2005 and the Tax (as % of total tax revenue) of St. Lucia in 2009?
Make the answer very short. 2.27. What is the difference between the Tax (as % of total tax revenue) in Burkina Faso in 2005 and the Tax (as % of total tax revenue) in Canada in 2010?
Your answer should be very brief. -53.19. What is the difference between the Tax (as % of total tax revenue) in Burkina Faso in 2005 and the Tax (as % of total tax revenue) in Peru in 2010?
Provide a succinct answer. -16.49. What is the difference between the Tax (as % of total tax revenue) in Burkina Faso in 2005 and the Tax (as % of total tax revenue) in St. Lucia in 2010?
Offer a terse response. -5.22. What is the difference between the Tax (as % of total tax revenue) of Canada in 2005 and the Tax (as % of total tax revenue) of Peru in 2010?
Keep it short and to the point. 34.25. What is the difference between the Tax (as % of total tax revenue) in Canada in 2005 and the Tax (as % of total tax revenue) in St. Lucia in 2010?
Your answer should be very brief. 45.52. What is the difference between the Tax (as % of total tax revenue) of Peru in 2005 and the Tax (as % of total tax revenue) of St. Lucia in 2010?
Offer a very short reply. 2.88. What is the difference between the Tax (as % of total tax revenue) in Burkina Faso in 2006 and the Tax (as % of total tax revenue) in Canada in 2007?
Offer a terse response. -53.45. What is the difference between the Tax (as % of total tax revenue) of Burkina Faso in 2006 and the Tax (as % of total tax revenue) of Peru in 2007?
Give a very brief answer. -20.32. What is the difference between the Tax (as % of total tax revenue) in Burkina Faso in 2006 and the Tax (as % of total tax revenue) in St. Lucia in 2007?
Offer a very short reply. -1.85. What is the difference between the Tax (as % of total tax revenue) in Canada in 2006 and the Tax (as % of total tax revenue) in Peru in 2007?
Give a very brief answer. 32.2. What is the difference between the Tax (as % of total tax revenue) of Canada in 2006 and the Tax (as % of total tax revenue) of St. Lucia in 2007?
Your answer should be very brief. 50.66. What is the difference between the Tax (as % of total tax revenue) of Peru in 2006 and the Tax (as % of total tax revenue) of St. Lucia in 2007?
Keep it short and to the point. 15.4. What is the difference between the Tax (as % of total tax revenue) in Burkina Faso in 2006 and the Tax (as % of total tax revenue) in Canada in 2008?
Provide a succinct answer. -55.05. What is the difference between the Tax (as % of total tax revenue) in Burkina Faso in 2006 and the Tax (as % of total tax revenue) in Peru in 2008?
Make the answer very short. -18.21. What is the difference between the Tax (as % of total tax revenue) in Burkina Faso in 2006 and the Tax (as % of total tax revenue) in St. Lucia in 2008?
Provide a short and direct response. -5.63. What is the difference between the Tax (as % of total tax revenue) in Canada in 2006 and the Tax (as % of total tax revenue) in Peru in 2008?
Give a very brief answer. 34.3. What is the difference between the Tax (as % of total tax revenue) of Canada in 2006 and the Tax (as % of total tax revenue) of St. Lucia in 2008?
Provide a succinct answer. 46.88. What is the difference between the Tax (as % of total tax revenue) of Peru in 2006 and the Tax (as % of total tax revenue) of St. Lucia in 2008?
Your answer should be compact. 11.62. What is the difference between the Tax (as % of total tax revenue) of Burkina Faso in 2006 and the Tax (as % of total tax revenue) of Canada in 2009?
Make the answer very short. -53.97. What is the difference between the Tax (as % of total tax revenue) in Burkina Faso in 2006 and the Tax (as % of total tax revenue) in Peru in 2009?
Give a very brief answer. -15.42. What is the difference between the Tax (as % of total tax revenue) of Burkina Faso in 2006 and the Tax (as % of total tax revenue) of St. Lucia in 2009?
Offer a very short reply. -6.1. What is the difference between the Tax (as % of total tax revenue) of Canada in 2006 and the Tax (as % of total tax revenue) of Peru in 2009?
Provide a short and direct response. 37.1. What is the difference between the Tax (as % of total tax revenue) of Canada in 2006 and the Tax (as % of total tax revenue) of St. Lucia in 2009?
Your answer should be very brief. 46.41. What is the difference between the Tax (as % of total tax revenue) in Peru in 2006 and the Tax (as % of total tax revenue) in St. Lucia in 2009?
Your response must be concise. 11.15. What is the difference between the Tax (as % of total tax revenue) in Burkina Faso in 2006 and the Tax (as % of total tax revenue) in Canada in 2010?
Offer a terse response. -53.47. What is the difference between the Tax (as % of total tax revenue) in Burkina Faso in 2006 and the Tax (as % of total tax revenue) in Peru in 2010?
Offer a very short reply. -16.77. What is the difference between the Tax (as % of total tax revenue) of Burkina Faso in 2006 and the Tax (as % of total tax revenue) of St. Lucia in 2010?
Make the answer very short. -5.5. What is the difference between the Tax (as % of total tax revenue) in Canada in 2006 and the Tax (as % of total tax revenue) in Peru in 2010?
Offer a very short reply. 35.74. What is the difference between the Tax (as % of total tax revenue) in Canada in 2006 and the Tax (as % of total tax revenue) in St. Lucia in 2010?
Your response must be concise. 47.01. What is the difference between the Tax (as % of total tax revenue) of Peru in 2006 and the Tax (as % of total tax revenue) of St. Lucia in 2010?
Provide a short and direct response. 11.75. What is the difference between the Tax (as % of total tax revenue) in Burkina Faso in 2007 and the Tax (as % of total tax revenue) in Canada in 2008?
Offer a terse response. -54.46. What is the difference between the Tax (as % of total tax revenue) of Burkina Faso in 2007 and the Tax (as % of total tax revenue) of Peru in 2008?
Provide a short and direct response. -17.63. What is the difference between the Tax (as % of total tax revenue) of Burkina Faso in 2007 and the Tax (as % of total tax revenue) of St. Lucia in 2008?
Keep it short and to the point. -5.05. What is the difference between the Tax (as % of total tax revenue) of Canada in 2007 and the Tax (as % of total tax revenue) of Peru in 2008?
Your answer should be very brief. 35.23. What is the difference between the Tax (as % of total tax revenue) in Canada in 2007 and the Tax (as % of total tax revenue) in St. Lucia in 2008?
Offer a very short reply. 47.82. What is the difference between the Tax (as % of total tax revenue) of Peru in 2007 and the Tax (as % of total tax revenue) of St. Lucia in 2008?
Make the answer very short. 14.69. What is the difference between the Tax (as % of total tax revenue) of Burkina Faso in 2007 and the Tax (as % of total tax revenue) of Canada in 2009?
Provide a short and direct response. -53.38. What is the difference between the Tax (as % of total tax revenue) in Burkina Faso in 2007 and the Tax (as % of total tax revenue) in Peru in 2009?
Your answer should be very brief. -14.83. What is the difference between the Tax (as % of total tax revenue) in Burkina Faso in 2007 and the Tax (as % of total tax revenue) in St. Lucia in 2009?
Give a very brief answer. -5.52. What is the difference between the Tax (as % of total tax revenue) in Canada in 2007 and the Tax (as % of total tax revenue) in Peru in 2009?
Provide a short and direct response. 38.03. What is the difference between the Tax (as % of total tax revenue) in Canada in 2007 and the Tax (as % of total tax revenue) in St. Lucia in 2009?
Provide a short and direct response. 47.35. What is the difference between the Tax (as % of total tax revenue) of Peru in 2007 and the Tax (as % of total tax revenue) of St. Lucia in 2009?
Give a very brief answer. 14.21. What is the difference between the Tax (as % of total tax revenue) of Burkina Faso in 2007 and the Tax (as % of total tax revenue) of Canada in 2010?
Provide a short and direct response. -52.88. What is the difference between the Tax (as % of total tax revenue) of Burkina Faso in 2007 and the Tax (as % of total tax revenue) of Peru in 2010?
Your answer should be very brief. -16.18. What is the difference between the Tax (as % of total tax revenue) in Burkina Faso in 2007 and the Tax (as % of total tax revenue) in St. Lucia in 2010?
Offer a terse response. -4.91. What is the difference between the Tax (as % of total tax revenue) of Canada in 2007 and the Tax (as % of total tax revenue) of Peru in 2010?
Your answer should be compact. 36.68. What is the difference between the Tax (as % of total tax revenue) of Canada in 2007 and the Tax (as % of total tax revenue) of St. Lucia in 2010?
Provide a succinct answer. 47.95. What is the difference between the Tax (as % of total tax revenue) in Peru in 2007 and the Tax (as % of total tax revenue) in St. Lucia in 2010?
Provide a short and direct response. 14.82. What is the difference between the Tax (as % of total tax revenue) of Burkina Faso in 2008 and the Tax (as % of total tax revenue) of Canada in 2009?
Your response must be concise. -53.95. What is the difference between the Tax (as % of total tax revenue) in Burkina Faso in 2008 and the Tax (as % of total tax revenue) in Peru in 2009?
Keep it short and to the point. -15.4. What is the difference between the Tax (as % of total tax revenue) of Burkina Faso in 2008 and the Tax (as % of total tax revenue) of St. Lucia in 2009?
Offer a terse response. -6.09. What is the difference between the Tax (as % of total tax revenue) in Canada in 2008 and the Tax (as % of total tax revenue) in Peru in 2009?
Make the answer very short. 39.63. What is the difference between the Tax (as % of total tax revenue) of Canada in 2008 and the Tax (as % of total tax revenue) of St. Lucia in 2009?
Your answer should be very brief. 48.95. What is the difference between the Tax (as % of total tax revenue) in Peru in 2008 and the Tax (as % of total tax revenue) in St. Lucia in 2009?
Give a very brief answer. 12.11. What is the difference between the Tax (as % of total tax revenue) of Burkina Faso in 2008 and the Tax (as % of total tax revenue) of Canada in 2010?
Your answer should be very brief. -53.46. What is the difference between the Tax (as % of total tax revenue) in Burkina Faso in 2008 and the Tax (as % of total tax revenue) in Peru in 2010?
Your response must be concise. -16.76. What is the difference between the Tax (as % of total tax revenue) in Burkina Faso in 2008 and the Tax (as % of total tax revenue) in St. Lucia in 2010?
Give a very brief answer. -5.49. What is the difference between the Tax (as % of total tax revenue) of Canada in 2008 and the Tax (as % of total tax revenue) of Peru in 2010?
Provide a succinct answer. 38.28. What is the difference between the Tax (as % of total tax revenue) in Canada in 2008 and the Tax (as % of total tax revenue) in St. Lucia in 2010?
Your response must be concise. 49.55. What is the difference between the Tax (as % of total tax revenue) in Peru in 2008 and the Tax (as % of total tax revenue) in St. Lucia in 2010?
Your answer should be compact. 12.71. What is the difference between the Tax (as % of total tax revenue) of Burkina Faso in 2009 and the Tax (as % of total tax revenue) of Canada in 2010?
Offer a very short reply. -55.15. What is the difference between the Tax (as % of total tax revenue) of Burkina Faso in 2009 and the Tax (as % of total tax revenue) of Peru in 2010?
Your answer should be compact. -18.45. What is the difference between the Tax (as % of total tax revenue) of Burkina Faso in 2009 and the Tax (as % of total tax revenue) of St. Lucia in 2010?
Offer a terse response. -7.18. What is the difference between the Tax (as % of total tax revenue) in Canada in 2009 and the Tax (as % of total tax revenue) in Peru in 2010?
Give a very brief answer. 37.2. What is the difference between the Tax (as % of total tax revenue) of Canada in 2009 and the Tax (as % of total tax revenue) of St. Lucia in 2010?
Your answer should be compact. 48.47. What is the difference between the Tax (as % of total tax revenue) of Peru in 2009 and the Tax (as % of total tax revenue) of St. Lucia in 2010?
Your response must be concise. 9.92. What is the average Tax (as % of total tax revenue) of Burkina Faso per year?
Give a very brief answer. 23.29. What is the average Tax (as % of total tax revenue) in Canada per year?
Your answer should be very brief. 75.7. What is the average Tax (as % of total tax revenue) in Peru per year?
Your answer should be compact. 37.1. What is the average Tax (as % of total tax revenue) in St. Lucia per year?
Ensure brevity in your answer.  25.55. In the year 2003, what is the difference between the Tax (as % of total tax revenue) in Burkina Faso and Tax (as % of total tax revenue) in Canada?
Provide a succinct answer. -47.98. In the year 2003, what is the difference between the Tax (as % of total tax revenue) of Burkina Faso and Tax (as % of total tax revenue) of Peru?
Your answer should be very brief. -5.84. In the year 2003, what is the difference between the Tax (as % of total tax revenue) in Burkina Faso and Tax (as % of total tax revenue) in St. Lucia?
Your answer should be compact. 1.29. In the year 2003, what is the difference between the Tax (as % of total tax revenue) in Canada and Tax (as % of total tax revenue) in Peru?
Your response must be concise. 42.14. In the year 2003, what is the difference between the Tax (as % of total tax revenue) of Canada and Tax (as % of total tax revenue) of St. Lucia?
Offer a terse response. 49.27. In the year 2003, what is the difference between the Tax (as % of total tax revenue) in Peru and Tax (as % of total tax revenue) in St. Lucia?
Give a very brief answer. 7.13. In the year 2004, what is the difference between the Tax (as % of total tax revenue) in Burkina Faso and Tax (as % of total tax revenue) in Canada?
Your answer should be compact. -51.39. In the year 2004, what is the difference between the Tax (as % of total tax revenue) in Burkina Faso and Tax (as % of total tax revenue) in Peru?
Make the answer very short. -7.84. In the year 2004, what is the difference between the Tax (as % of total tax revenue) in Canada and Tax (as % of total tax revenue) in Peru?
Provide a succinct answer. 43.55. In the year 2004, what is the difference between the Tax (as % of total tax revenue) of Canada and Tax (as % of total tax revenue) of St. Lucia?
Your answer should be compact. 52.19. In the year 2004, what is the difference between the Tax (as % of total tax revenue) of Peru and Tax (as % of total tax revenue) of St. Lucia?
Make the answer very short. 8.64. In the year 2005, what is the difference between the Tax (as % of total tax revenue) of Burkina Faso and Tax (as % of total tax revenue) of Canada?
Provide a short and direct response. -50.74. In the year 2005, what is the difference between the Tax (as % of total tax revenue) of Burkina Faso and Tax (as % of total tax revenue) of Peru?
Ensure brevity in your answer.  -8.1. In the year 2005, what is the difference between the Tax (as % of total tax revenue) in Burkina Faso and Tax (as % of total tax revenue) in St. Lucia?
Offer a terse response. -0.67. In the year 2005, what is the difference between the Tax (as % of total tax revenue) of Canada and Tax (as % of total tax revenue) of Peru?
Provide a short and direct response. 42.64. In the year 2005, what is the difference between the Tax (as % of total tax revenue) of Canada and Tax (as % of total tax revenue) of St. Lucia?
Provide a short and direct response. 50.08. In the year 2005, what is the difference between the Tax (as % of total tax revenue) of Peru and Tax (as % of total tax revenue) of St. Lucia?
Make the answer very short. 7.43. In the year 2006, what is the difference between the Tax (as % of total tax revenue) of Burkina Faso and Tax (as % of total tax revenue) of Canada?
Provide a succinct answer. -52.51. In the year 2006, what is the difference between the Tax (as % of total tax revenue) of Burkina Faso and Tax (as % of total tax revenue) of Peru?
Make the answer very short. -17.25. In the year 2006, what is the difference between the Tax (as % of total tax revenue) in Burkina Faso and Tax (as % of total tax revenue) in St. Lucia?
Keep it short and to the point. 0.35. In the year 2006, what is the difference between the Tax (as % of total tax revenue) in Canada and Tax (as % of total tax revenue) in Peru?
Your response must be concise. 35.26. In the year 2006, what is the difference between the Tax (as % of total tax revenue) in Canada and Tax (as % of total tax revenue) in St. Lucia?
Your answer should be compact. 52.86. In the year 2006, what is the difference between the Tax (as % of total tax revenue) in Peru and Tax (as % of total tax revenue) in St. Lucia?
Make the answer very short. 17.6. In the year 2007, what is the difference between the Tax (as % of total tax revenue) in Burkina Faso and Tax (as % of total tax revenue) in Canada?
Give a very brief answer. -52.86. In the year 2007, what is the difference between the Tax (as % of total tax revenue) of Burkina Faso and Tax (as % of total tax revenue) of Peru?
Provide a short and direct response. -19.73. In the year 2007, what is the difference between the Tax (as % of total tax revenue) in Burkina Faso and Tax (as % of total tax revenue) in St. Lucia?
Ensure brevity in your answer.  -1.27. In the year 2007, what is the difference between the Tax (as % of total tax revenue) in Canada and Tax (as % of total tax revenue) in Peru?
Offer a very short reply. 33.13. In the year 2007, what is the difference between the Tax (as % of total tax revenue) of Canada and Tax (as % of total tax revenue) of St. Lucia?
Offer a very short reply. 51.6. In the year 2007, what is the difference between the Tax (as % of total tax revenue) in Peru and Tax (as % of total tax revenue) in St. Lucia?
Provide a short and direct response. 18.47. In the year 2008, what is the difference between the Tax (as % of total tax revenue) of Burkina Faso and Tax (as % of total tax revenue) of Canada?
Your answer should be compact. -55.04. In the year 2008, what is the difference between the Tax (as % of total tax revenue) of Burkina Faso and Tax (as % of total tax revenue) of Peru?
Keep it short and to the point. -18.2. In the year 2008, what is the difference between the Tax (as % of total tax revenue) in Burkina Faso and Tax (as % of total tax revenue) in St. Lucia?
Provide a succinct answer. -5.62. In the year 2008, what is the difference between the Tax (as % of total tax revenue) of Canada and Tax (as % of total tax revenue) of Peru?
Your response must be concise. 36.84. In the year 2008, what is the difference between the Tax (as % of total tax revenue) of Canada and Tax (as % of total tax revenue) of St. Lucia?
Keep it short and to the point. 49.42. In the year 2008, what is the difference between the Tax (as % of total tax revenue) of Peru and Tax (as % of total tax revenue) of St. Lucia?
Provide a succinct answer. 12.58. In the year 2009, what is the difference between the Tax (as % of total tax revenue) in Burkina Faso and Tax (as % of total tax revenue) in Canada?
Offer a very short reply. -55.65. In the year 2009, what is the difference between the Tax (as % of total tax revenue) in Burkina Faso and Tax (as % of total tax revenue) in Peru?
Your answer should be compact. -17.1. In the year 2009, what is the difference between the Tax (as % of total tax revenue) of Burkina Faso and Tax (as % of total tax revenue) of St. Lucia?
Offer a terse response. -7.79. In the year 2009, what is the difference between the Tax (as % of total tax revenue) of Canada and Tax (as % of total tax revenue) of Peru?
Keep it short and to the point. 38.55. In the year 2009, what is the difference between the Tax (as % of total tax revenue) in Canada and Tax (as % of total tax revenue) in St. Lucia?
Offer a very short reply. 47.86. In the year 2009, what is the difference between the Tax (as % of total tax revenue) of Peru and Tax (as % of total tax revenue) of St. Lucia?
Make the answer very short. 9.31. In the year 2010, what is the difference between the Tax (as % of total tax revenue) in Burkina Faso and Tax (as % of total tax revenue) in Canada?
Your response must be concise. -53.11. In the year 2010, what is the difference between the Tax (as % of total tax revenue) in Burkina Faso and Tax (as % of total tax revenue) in Peru?
Ensure brevity in your answer.  -16.41. In the year 2010, what is the difference between the Tax (as % of total tax revenue) of Burkina Faso and Tax (as % of total tax revenue) of St. Lucia?
Your answer should be very brief. -5.14. In the year 2010, what is the difference between the Tax (as % of total tax revenue) of Canada and Tax (as % of total tax revenue) of Peru?
Provide a short and direct response. 36.7. In the year 2010, what is the difference between the Tax (as % of total tax revenue) of Canada and Tax (as % of total tax revenue) of St. Lucia?
Keep it short and to the point. 47.97. In the year 2010, what is the difference between the Tax (as % of total tax revenue) of Peru and Tax (as % of total tax revenue) of St. Lucia?
Your response must be concise. 11.27. What is the ratio of the Tax (as % of total tax revenue) of Burkina Faso in 2003 to that in 2004?
Keep it short and to the point. 1.11. What is the ratio of the Tax (as % of total tax revenue) in Canada in 2003 to that in 2004?
Give a very brief answer. 0.99. What is the ratio of the Tax (as % of total tax revenue) of Peru in 2003 to that in 2004?
Offer a very short reply. 1.01. What is the ratio of the Tax (as % of total tax revenue) in St. Lucia in 2003 to that in 2004?
Provide a succinct answer. 1.09. What is the ratio of the Tax (as % of total tax revenue) in Burkina Faso in 2003 to that in 2005?
Provide a succinct answer. 1.05. What is the ratio of the Tax (as % of total tax revenue) in Canada in 2003 to that in 2005?
Offer a very short reply. 0.98. What is the ratio of the Tax (as % of total tax revenue) in Peru in 2003 to that in 2005?
Provide a short and direct response. 0.97. What is the ratio of the Tax (as % of total tax revenue) in St. Lucia in 2003 to that in 2005?
Offer a very short reply. 0.97. What is the ratio of the Tax (as % of total tax revenue) of Burkina Faso in 2003 to that in 2006?
Keep it short and to the point. 1.07. What is the ratio of the Tax (as % of total tax revenue) in Canada in 2003 to that in 2006?
Provide a succinct answer. 0.96. What is the ratio of the Tax (as % of total tax revenue) of Peru in 2003 to that in 2006?
Provide a short and direct response. 0.76. What is the ratio of the Tax (as % of total tax revenue) in St. Lucia in 2003 to that in 2006?
Give a very brief answer. 1.03. What is the ratio of the Tax (as % of total tax revenue) in Burkina Faso in 2003 to that in 2007?
Offer a very short reply. 1.04. What is the ratio of the Tax (as % of total tax revenue) in Canada in 2003 to that in 2007?
Your answer should be very brief. 0.95. What is the ratio of the Tax (as % of total tax revenue) of Peru in 2003 to that in 2007?
Your answer should be compact. 0.7. What is the ratio of the Tax (as % of total tax revenue) in St. Lucia in 2003 to that in 2007?
Provide a succinct answer. 0.94. What is the ratio of the Tax (as % of total tax revenue) of Burkina Faso in 2003 to that in 2008?
Your response must be concise. 1.07. What is the ratio of the Tax (as % of total tax revenue) of Canada in 2003 to that in 2008?
Offer a very short reply. 0.93. What is the ratio of the Tax (as % of total tax revenue) of Peru in 2003 to that in 2008?
Provide a short and direct response. 0.74. What is the ratio of the Tax (as % of total tax revenue) in St. Lucia in 2003 to that in 2008?
Offer a very short reply. 0.81. What is the ratio of the Tax (as % of total tax revenue) of Burkina Faso in 2003 to that in 2009?
Offer a terse response. 1.15. What is the ratio of the Tax (as % of total tax revenue) in Canada in 2003 to that in 2009?
Provide a succinct answer. 0.94. What is the ratio of the Tax (as % of total tax revenue) in Peru in 2003 to that in 2009?
Offer a very short reply. 0.79. What is the ratio of the Tax (as % of total tax revenue) in St. Lucia in 2003 to that in 2009?
Provide a short and direct response. 0.8. What is the ratio of the Tax (as % of total tax revenue) in Burkina Faso in 2003 to that in 2010?
Give a very brief answer. 1.05. What is the ratio of the Tax (as % of total tax revenue) of Canada in 2003 to that in 2010?
Make the answer very short. 0.95. What is the ratio of the Tax (as % of total tax revenue) in Peru in 2003 to that in 2010?
Ensure brevity in your answer.  0.77. What is the ratio of the Tax (as % of total tax revenue) in St. Lucia in 2003 to that in 2010?
Provide a succinct answer. 0.82. What is the ratio of the Tax (as % of total tax revenue) in Burkina Faso in 2004 to that in 2005?
Ensure brevity in your answer.  0.95. What is the ratio of the Tax (as % of total tax revenue) in Canada in 2004 to that in 2005?
Your response must be concise. 0.99. What is the ratio of the Tax (as % of total tax revenue) of Peru in 2004 to that in 2005?
Give a very brief answer. 0.96. What is the ratio of the Tax (as % of total tax revenue) in St. Lucia in 2004 to that in 2005?
Give a very brief answer. 0.89. What is the ratio of the Tax (as % of total tax revenue) of Burkina Faso in 2004 to that in 2006?
Your answer should be compact. 0.96. What is the ratio of the Tax (as % of total tax revenue) of Canada in 2004 to that in 2006?
Your answer should be compact. 0.97. What is the ratio of the Tax (as % of total tax revenue) in Peru in 2004 to that in 2006?
Offer a terse response. 0.75. What is the ratio of the Tax (as % of total tax revenue) of St. Lucia in 2004 to that in 2006?
Provide a succinct answer. 0.94. What is the ratio of the Tax (as % of total tax revenue) in Canada in 2004 to that in 2007?
Offer a terse response. 0.96. What is the ratio of the Tax (as % of total tax revenue) in Peru in 2004 to that in 2007?
Provide a short and direct response. 0.69. What is the ratio of the Tax (as % of total tax revenue) of St. Lucia in 2004 to that in 2007?
Provide a short and direct response. 0.86. What is the ratio of the Tax (as % of total tax revenue) of Burkina Faso in 2004 to that in 2008?
Your answer should be compact. 0.96. What is the ratio of the Tax (as % of total tax revenue) in Canada in 2004 to that in 2008?
Make the answer very short. 0.94. What is the ratio of the Tax (as % of total tax revenue) of Peru in 2004 to that in 2008?
Your answer should be compact. 0.73. What is the ratio of the Tax (as % of total tax revenue) of St. Lucia in 2004 to that in 2008?
Provide a short and direct response. 0.75. What is the ratio of the Tax (as % of total tax revenue) of Burkina Faso in 2004 to that in 2009?
Keep it short and to the point. 1.04. What is the ratio of the Tax (as % of total tax revenue) in Canada in 2004 to that in 2009?
Offer a very short reply. 0.96. What is the ratio of the Tax (as % of total tax revenue) in Peru in 2004 to that in 2009?
Provide a succinct answer. 0.78. What is the ratio of the Tax (as % of total tax revenue) in St. Lucia in 2004 to that in 2009?
Your answer should be very brief. 0.74. What is the ratio of the Tax (as % of total tax revenue) in Burkina Faso in 2004 to that in 2010?
Your response must be concise. 0.95. What is the ratio of the Tax (as % of total tax revenue) of Canada in 2004 to that in 2010?
Offer a very short reply. 0.96. What is the ratio of the Tax (as % of total tax revenue) of Peru in 2004 to that in 2010?
Provide a short and direct response. 0.76. What is the ratio of the Tax (as % of total tax revenue) of St. Lucia in 2004 to that in 2010?
Your answer should be compact. 0.75. What is the ratio of the Tax (as % of total tax revenue) of Burkina Faso in 2005 to that in 2006?
Offer a very short reply. 1.01. What is the ratio of the Tax (as % of total tax revenue) in Canada in 2005 to that in 2006?
Offer a very short reply. 0.98. What is the ratio of the Tax (as % of total tax revenue) of Peru in 2005 to that in 2006?
Your answer should be very brief. 0.78. What is the ratio of the Tax (as % of total tax revenue) of St. Lucia in 2005 to that in 2006?
Keep it short and to the point. 1.06. What is the ratio of the Tax (as % of total tax revenue) in Canada in 2005 to that in 2007?
Keep it short and to the point. 0.97. What is the ratio of the Tax (as % of total tax revenue) of Peru in 2005 to that in 2007?
Provide a short and direct response. 0.73. What is the ratio of the Tax (as % of total tax revenue) of St. Lucia in 2005 to that in 2007?
Offer a very short reply. 0.96. What is the ratio of the Tax (as % of total tax revenue) in Burkina Faso in 2005 to that in 2008?
Provide a short and direct response. 1.01. What is the ratio of the Tax (as % of total tax revenue) of Canada in 2005 to that in 2008?
Keep it short and to the point. 0.95. What is the ratio of the Tax (as % of total tax revenue) in Peru in 2005 to that in 2008?
Give a very brief answer. 0.76. What is the ratio of the Tax (as % of total tax revenue) of St. Lucia in 2005 to that in 2008?
Offer a very short reply. 0.84. What is the ratio of the Tax (as % of total tax revenue) of Canada in 2005 to that in 2009?
Give a very brief answer. 0.96. What is the ratio of the Tax (as % of total tax revenue) in Peru in 2005 to that in 2009?
Provide a short and direct response. 0.82. What is the ratio of the Tax (as % of total tax revenue) in St. Lucia in 2005 to that in 2009?
Your answer should be very brief. 0.82. What is the ratio of the Tax (as % of total tax revenue) of Canada in 2005 to that in 2010?
Provide a short and direct response. 0.97. What is the ratio of the Tax (as % of total tax revenue) in Peru in 2005 to that in 2010?
Your answer should be compact. 0.79. What is the ratio of the Tax (as % of total tax revenue) in St. Lucia in 2005 to that in 2010?
Your answer should be very brief. 0.84. What is the ratio of the Tax (as % of total tax revenue) of Burkina Faso in 2006 to that in 2007?
Your response must be concise. 0.98. What is the ratio of the Tax (as % of total tax revenue) in Peru in 2006 to that in 2007?
Make the answer very short. 0.93. What is the ratio of the Tax (as % of total tax revenue) of St. Lucia in 2006 to that in 2007?
Your answer should be compact. 0.91. What is the ratio of the Tax (as % of total tax revenue) in Canada in 2006 to that in 2008?
Your answer should be compact. 0.97. What is the ratio of the Tax (as % of total tax revenue) of Peru in 2006 to that in 2008?
Ensure brevity in your answer.  0.98. What is the ratio of the Tax (as % of total tax revenue) of St. Lucia in 2006 to that in 2008?
Keep it short and to the point. 0.79. What is the ratio of the Tax (as % of total tax revenue) in Burkina Faso in 2006 to that in 2009?
Provide a succinct answer. 1.08. What is the ratio of the Tax (as % of total tax revenue) of Canada in 2006 to that in 2009?
Offer a very short reply. 0.98. What is the ratio of the Tax (as % of total tax revenue) of Peru in 2006 to that in 2009?
Ensure brevity in your answer.  1.05. What is the ratio of the Tax (as % of total tax revenue) in St. Lucia in 2006 to that in 2009?
Your answer should be compact. 0.78. What is the ratio of the Tax (as % of total tax revenue) of Burkina Faso in 2006 to that in 2010?
Keep it short and to the point. 0.98. What is the ratio of the Tax (as % of total tax revenue) of Canada in 2006 to that in 2010?
Provide a succinct answer. 0.99. What is the ratio of the Tax (as % of total tax revenue) of Peru in 2006 to that in 2010?
Keep it short and to the point. 1.01. What is the ratio of the Tax (as % of total tax revenue) in St. Lucia in 2006 to that in 2010?
Your answer should be compact. 0.8. What is the ratio of the Tax (as % of total tax revenue) in Burkina Faso in 2007 to that in 2008?
Your answer should be compact. 1.02. What is the ratio of the Tax (as % of total tax revenue) of Canada in 2007 to that in 2008?
Offer a very short reply. 0.98. What is the ratio of the Tax (as % of total tax revenue) of Peru in 2007 to that in 2008?
Keep it short and to the point. 1.05. What is the ratio of the Tax (as % of total tax revenue) of St. Lucia in 2007 to that in 2008?
Your answer should be compact. 0.87. What is the ratio of the Tax (as % of total tax revenue) in Burkina Faso in 2007 to that in 2009?
Keep it short and to the point. 1.11. What is the ratio of the Tax (as % of total tax revenue) of Peru in 2007 to that in 2009?
Give a very brief answer. 1.13. What is the ratio of the Tax (as % of total tax revenue) in St. Lucia in 2007 to that in 2009?
Offer a very short reply. 0.86. What is the ratio of the Tax (as % of total tax revenue) in Burkina Faso in 2007 to that in 2010?
Ensure brevity in your answer.  1.01. What is the ratio of the Tax (as % of total tax revenue) of Peru in 2007 to that in 2010?
Ensure brevity in your answer.  1.09. What is the ratio of the Tax (as % of total tax revenue) of St. Lucia in 2007 to that in 2010?
Your answer should be compact. 0.87. What is the ratio of the Tax (as % of total tax revenue) of Burkina Faso in 2008 to that in 2009?
Your response must be concise. 1.08. What is the ratio of the Tax (as % of total tax revenue) in Canada in 2008 to that in 2009?
Provide a succinct answer. 1.01. What is the ratio of the Tax (as % of total tax revenue) of Peru in 2008 to that in 2009?
Offer a terse response. 1.07. What is the ratio of the Tax (as % of total tax revenue) of St. Lucia in 2008 to that in 2009?
Your answer should be very brief. 0.98. What is the ratio of the Tax (as % of total tax revenue) in Burkina Faso in 2008 to that in 2010?
Ensure brevity in your answer.  0.99. What is the ratio of the Tax (as % of total tax revenue) of Canada in 2008 to that in 2010?
Give a very brief answer. 1.02. What is the ratio of the Tax (as % of total tax revenue) in Peru in 2008 to that in 2010?
Offer a terse response. 1.04. What is the ratio of the Tax (as % of total tax revenue) of Burkina Faso in 2009 to that in 2010?
Give a very brief answer. 0.91. What is the ratio of the Tax (as % of total tax revenue) of Peru in 2009 to that in 2010?
Give a very brief answer. 0.97. What is the difference between the highest and the second highest Tax (as % of total tax revenue) in Burkina Faso?
Provide a short and direct response. 0.96. What is the difference between the highest and the second highest Tax (as % of total tax revenue) in Canada?
Keep it short and to the point. 1.08. What is the difference between the highest and the second highest Tax (as % of total tax revenue) in Peru?
Give a very brief answer. 2.1. What is the difference between the highest and the second highest Tax (as % of total tax revenue) in St. Lucia?
Offer a terse response. 0.47. What is the difference between the highest and the lowest Tax (as % of total tax revenue) of Burkina Faso?
Your response must be concise. 3.23. What is the difference between the highest and the lowest Tax (as % of total tax revenue) of Canada?
Make the answer very short. 5.52. What is the difference between the highest and the lowest Tax (as % of total tax revenue) in Peru?
Your answer should be compact. 13.3. What is the difference between the highest and the lowest Tax (as % of total tax revenue) of St. Lucia?
Your answer should be very brief. 7.72. 